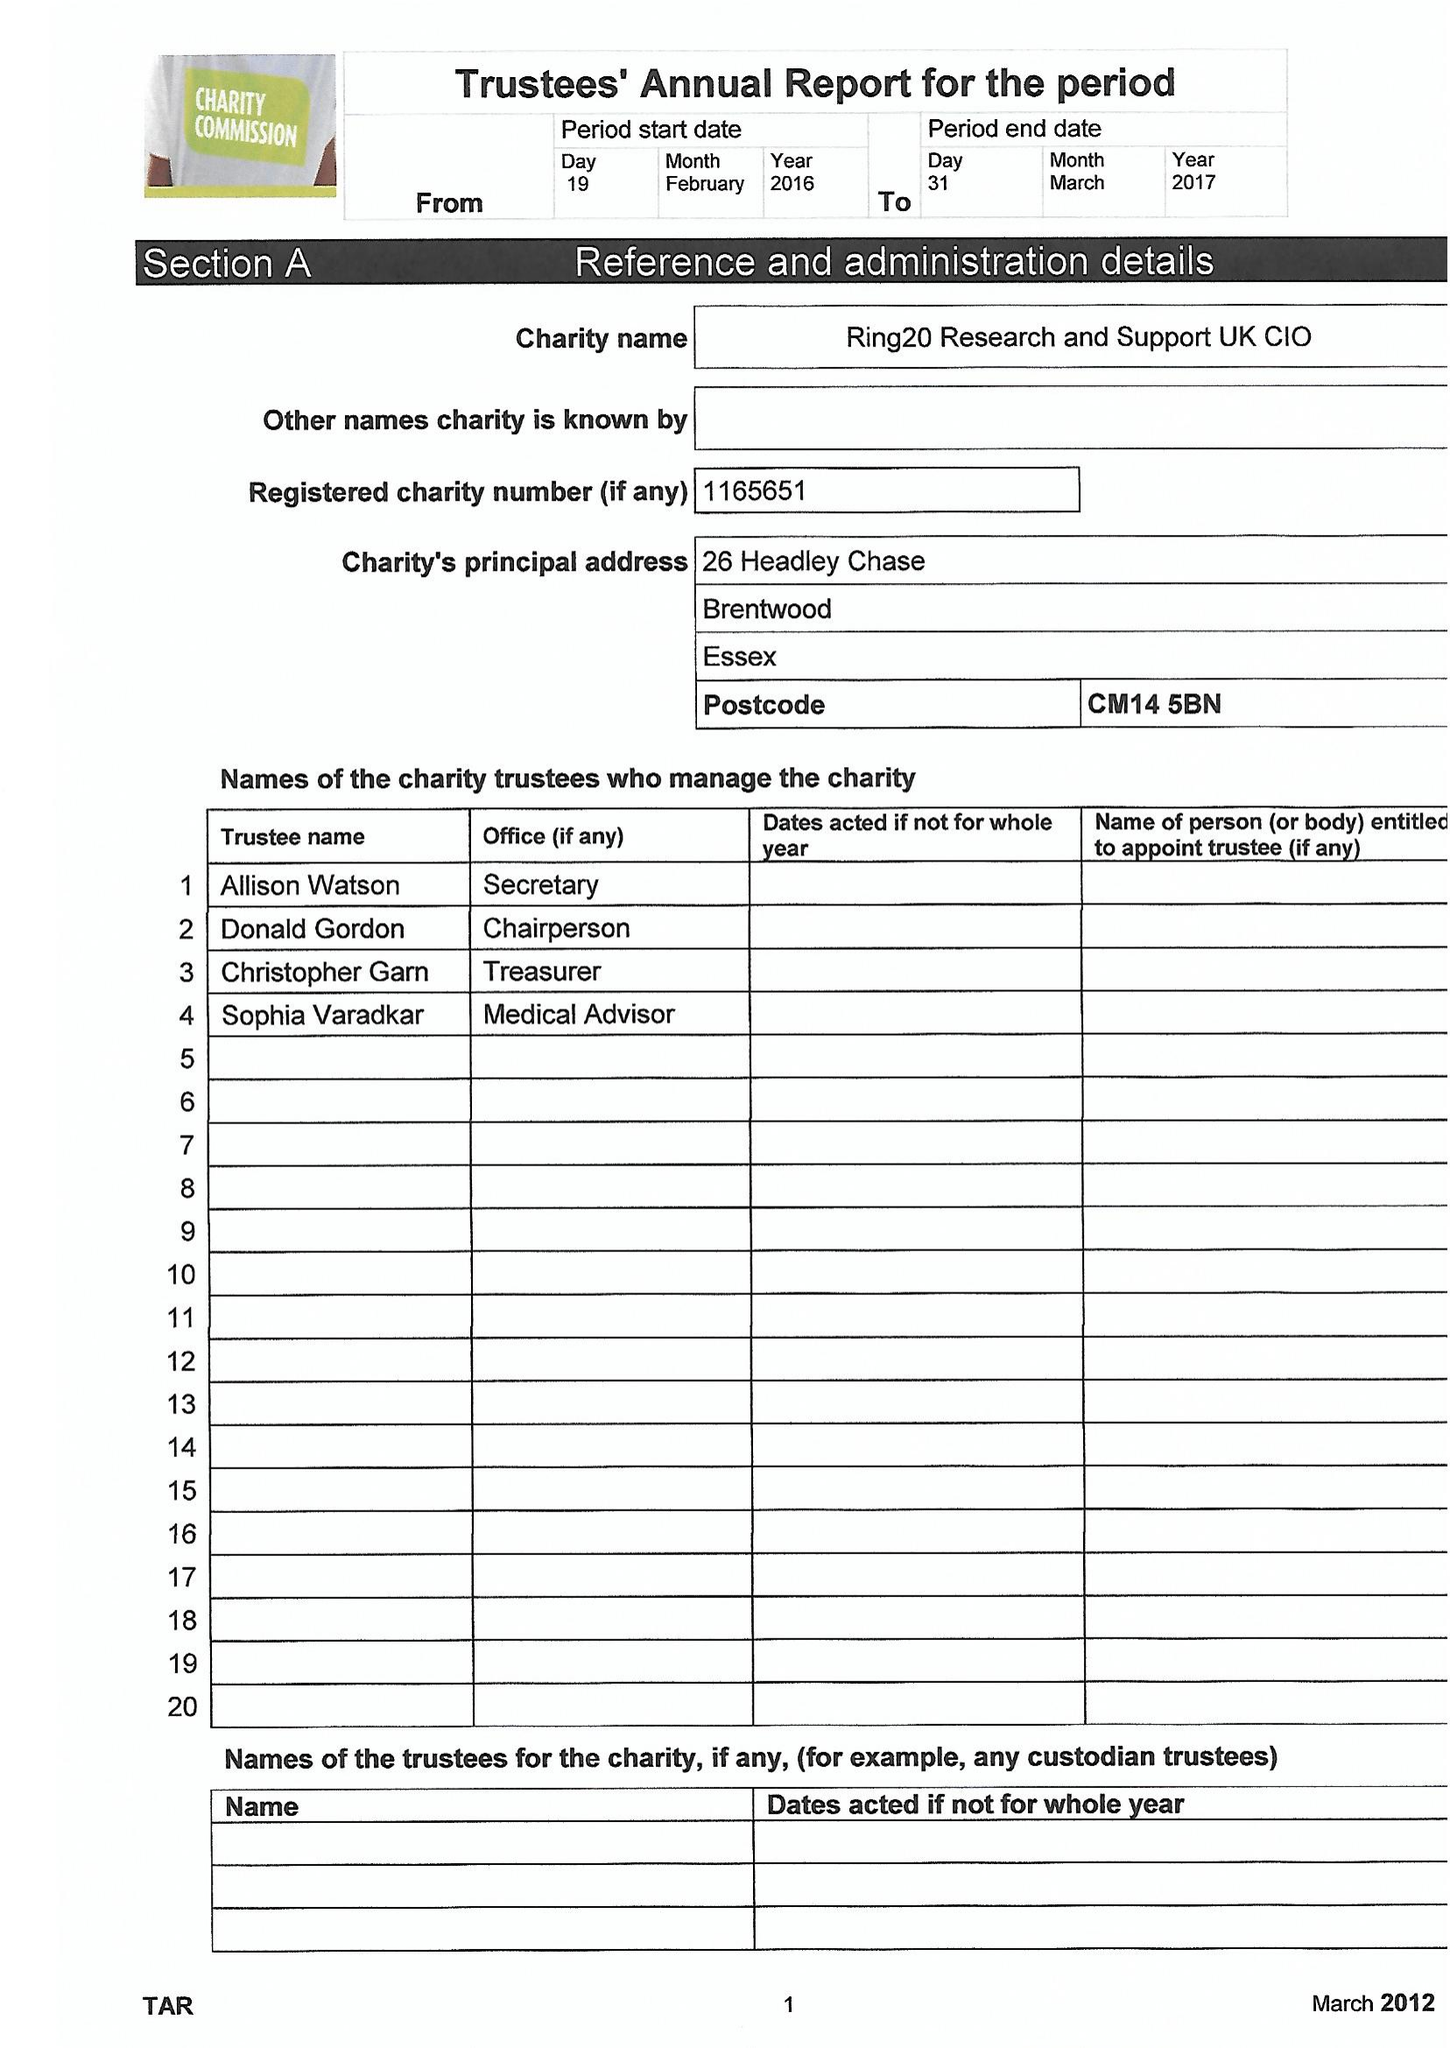What is the value for the charity_name?
Answer the question using a single word or phrase. Ring20 Research and Support Uk CIO 